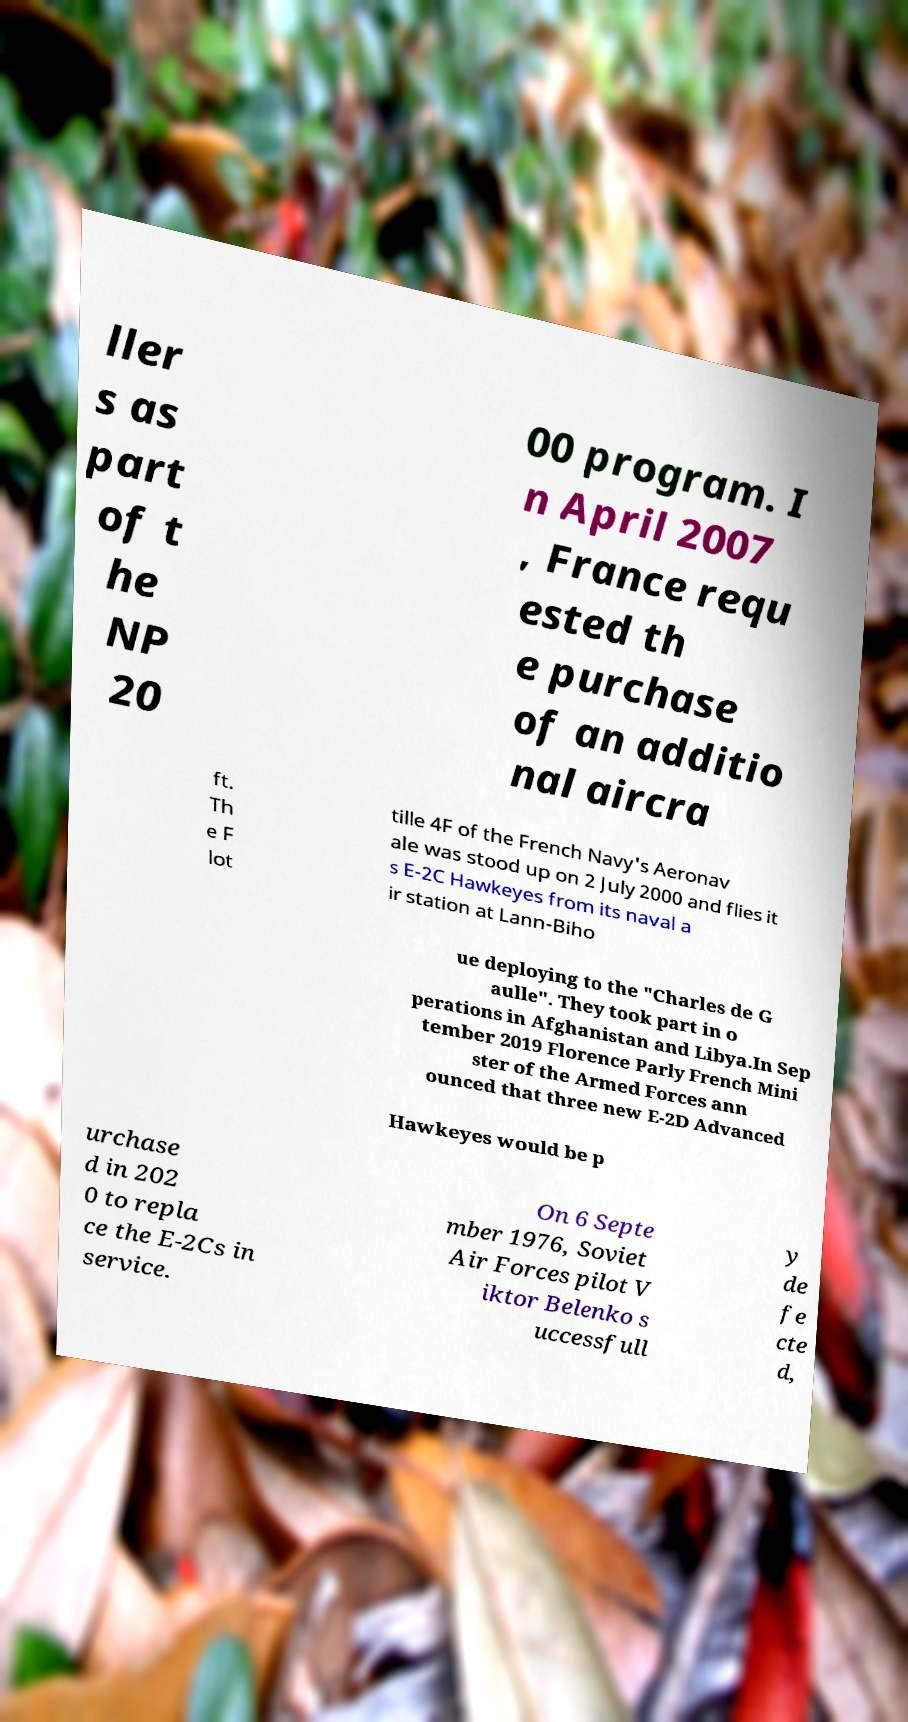Can you accurately transcribe the text from the provided image for me? ller s as part of t he NP 20 00 program. I n April 2007 , France requ ested th e purchase of an additio nal aircra ft. Th e F lot tille 4F of the French Navy's Aeronav ale was stood up on 2 July 2000 and flies it s E-2C Hawkeyes from its naval a ir station at Lann-Biho ue deploying to the "Charles de G aulle". They took part in o perations in Afghanistan and Libya.In Sep tember 2019 Florence Parly French Mini ster of the Armed Forces ann ounced that three new E-2D Advanced Hawkeyes would be p urchase d in 202 0 to repla ce the E-2Cs in service. On 6 Septe mber 1976, Soviet Air Forces pilot V iktor Belenko s uccessfull y de fe cte d, 